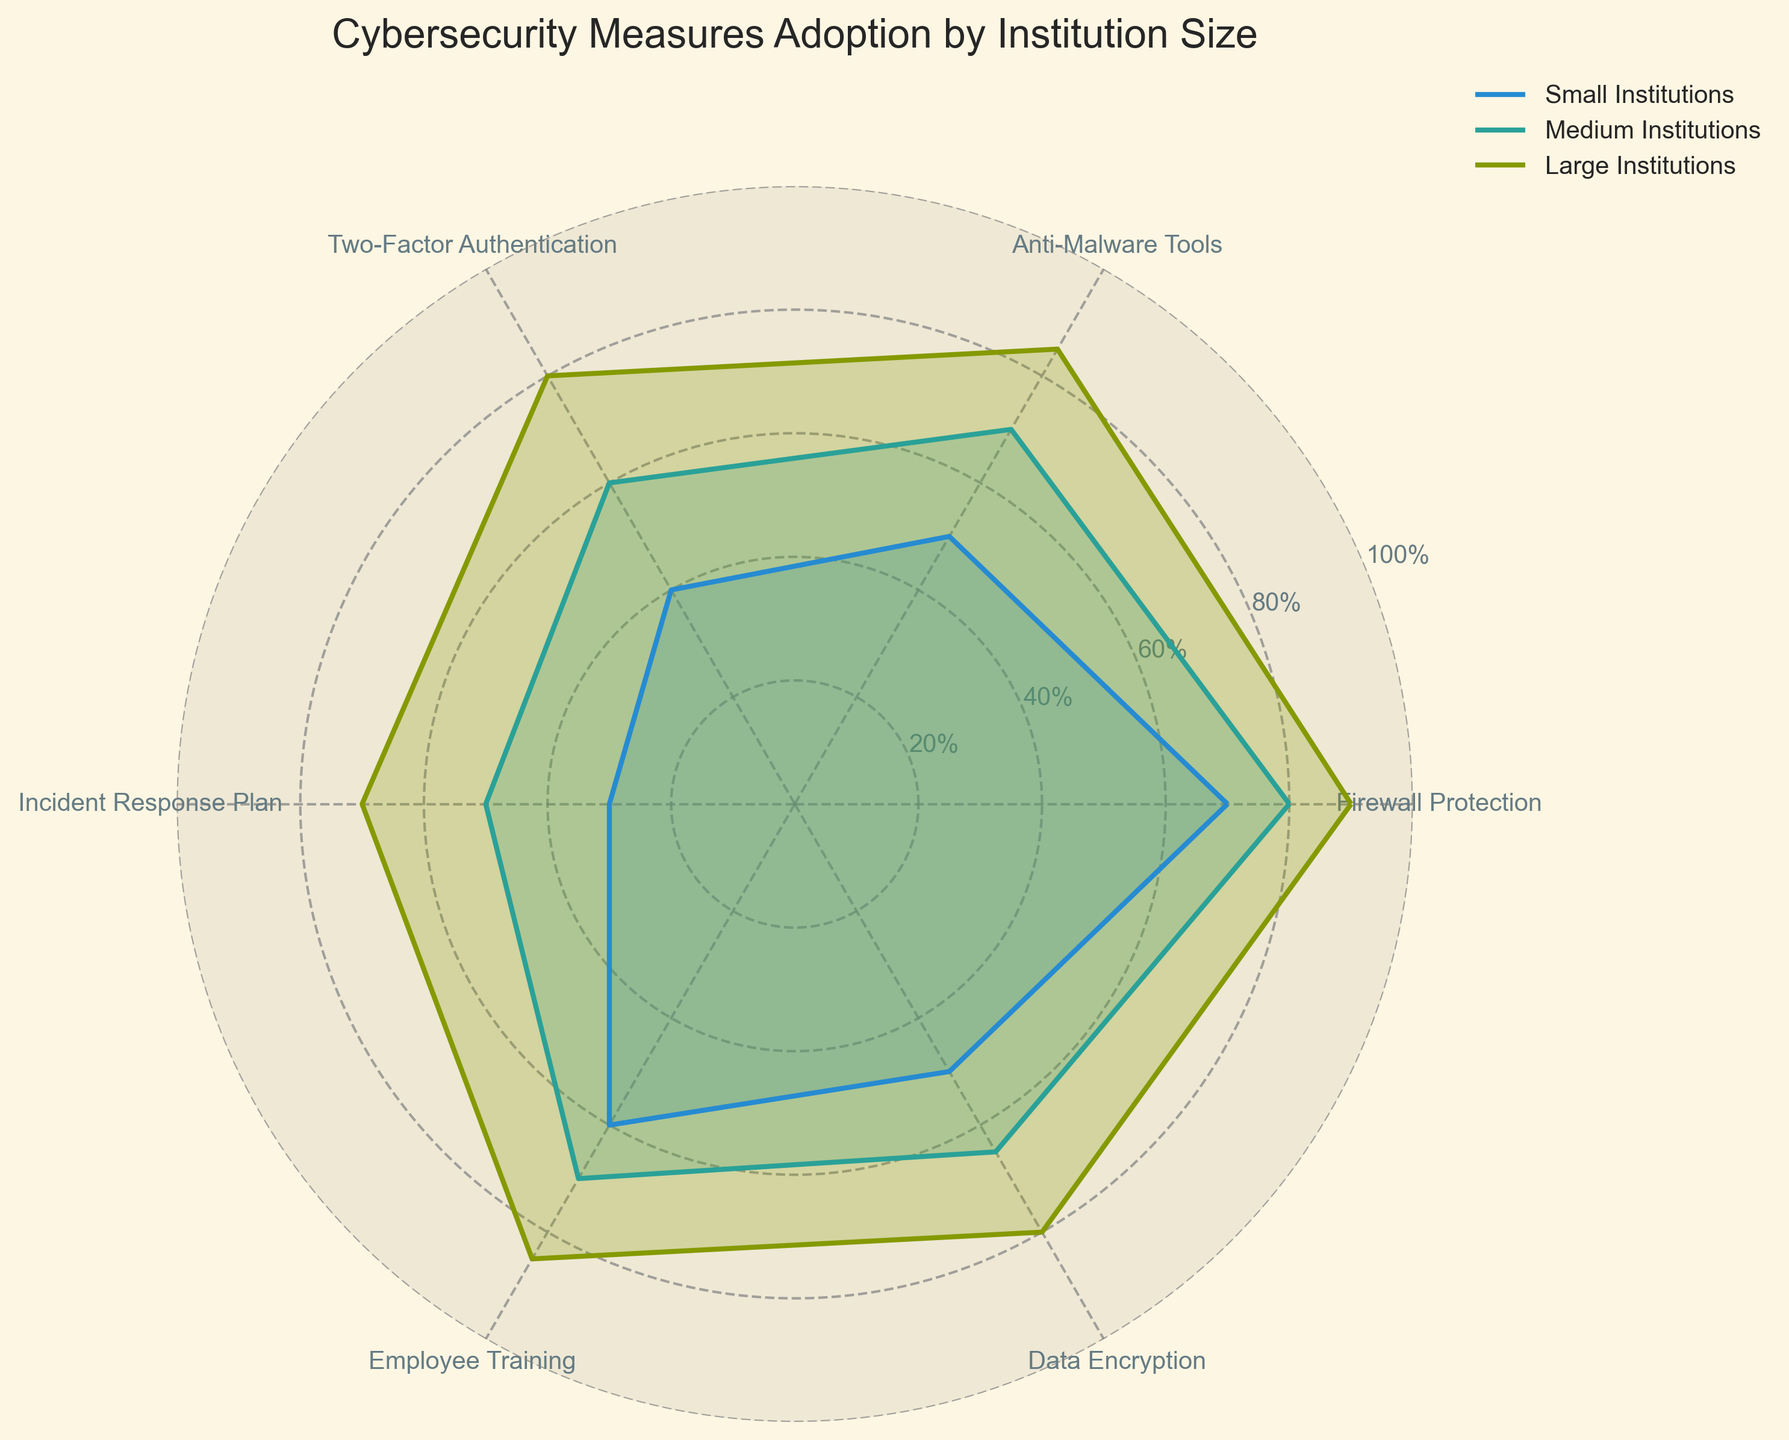What is the title of the radar chart? The title of the radar chart is displayed at the top center. Reading the text there provides the title.
Answer: "Cybersecurity Measures Adoption by Institution Size" How many categories are compared across the different institution sizes in the radar chart? The categories are represented by the axis ticks around the radar chart. By counting these, you can determine the number of categories.
Answer: 6 Which institution size has the highest percentage of Data Encryption adoption? Look at the Data Encryption axis and see which institution size has the highest value on this axis.
Answer: Large Institutions What is the difference in Firewall Protection adoption between Small and Medium Institutions? Locate the values on the Firewall Protection axis for both Small and Medium Institutions and subtract the smaller value from the larger one.
Answer: 10% Do Medium Institutions or Large Institutions have a higher score for Two-Factor Authentication? Compare the values on the Two-Factor Authentication axis for both Medium and Large Institutions to see which is higher.
Answer: Large Institutions Which category shows the least variation in adoption rates across institution sizes? Identify the ranges of values for each category by subtracting the smallest value from the largest for each category. The one with the smallest range shows the least variation.
Answer: Firewall Protection What is the average adoption rate of Incident Response Plan for all institution sizes? Sum the values of Incident Response Plan for Small, Medium, and Large Institutions and then divide by the number of institution sizes (3).
Answer: 50% Do Small Institutions perform better in Employee Training or Anti-Malware Tools? Compare the values on the Employee Training and Anti-Malware Tools axes for Small Institutions to see which is higher.
Answer: Employee Training Which institution size shows the most balanced adoption rates across all categories? Look at the shapes formed by the lines in the radar chart for each institution size. The most balanced shape (closest to a regular polygon) indicates the most balanced adoption rates.
Answer: Large Institutions By how much do Large Institutions exceed Small Institutions in Data Encryption? Find the values for Data Encryption for both Large and Small Institutions and subtract the smaller value from the larger one.
Answer: 30% 